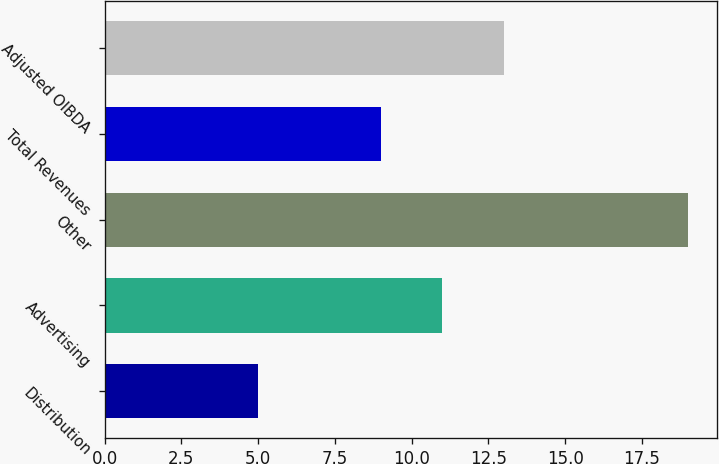Convert chart. <chart><loc_0><loc_0><loc_500><loc_500><bar_chart><fcel>Distribution<fcel>Advertising<fcel>Other<fcel>Total Revenues<fcel>Adjusted OIBDA<nl><fcel>5<fcel>11<fcel>19<fcel>9<fcel>13<nl></chart> 